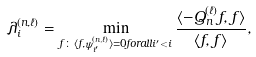Convert formula to latex. <formula><loc_0><loc_0><loc_500><loc_500>\lambda _ { i } ^ { ( n , \ell ) } = \min _ { f \colon \langle f , \psi _ { i ^ { \prime } } ^ { ( n , \ell ) } \rangle = 0 f o r a l l i ^ { \prime } < i } \frac { \langle - Q _ { n } ^ { ( \ell ) } f , f \rangle } { \langle f , f \rangle } ,</formula> 